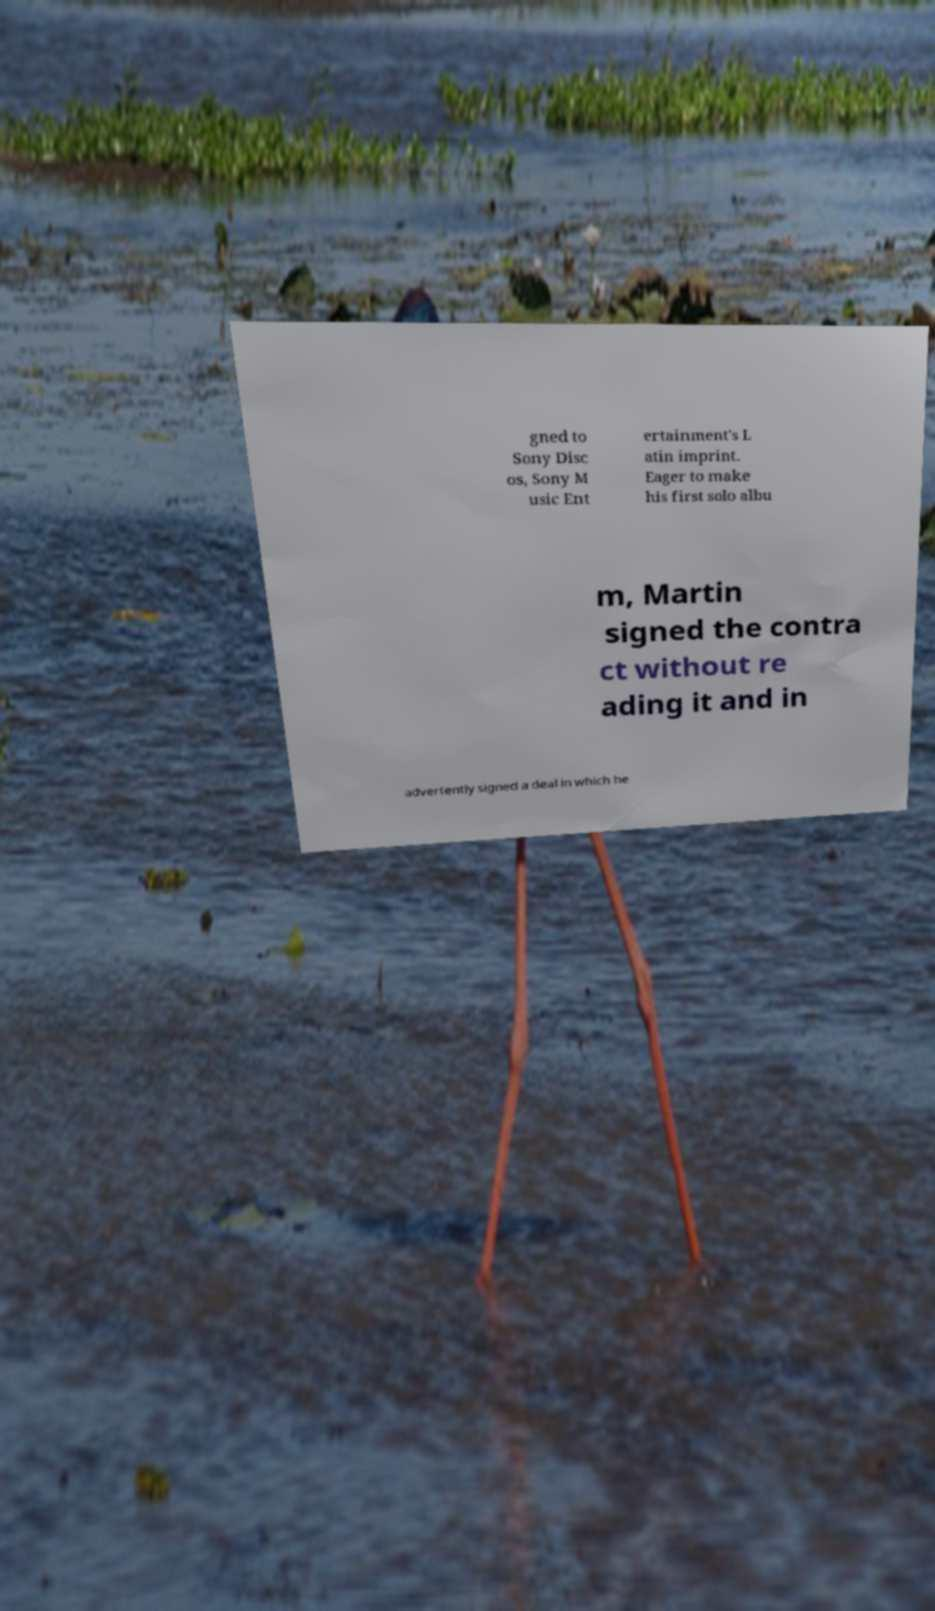Could you assist in decoding the text presented in this image and type it out clearly? gned to Sony Disc os, Sony M usic Ent ertainment's L atin imprint. Eager to make his first solo albu m, Martin signed the contra ct without re ading it and in advertently signed a deal in which he 